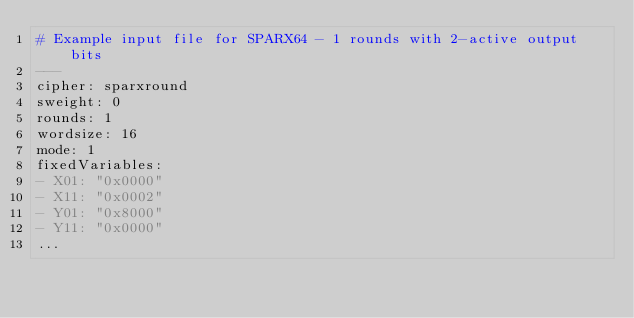<code> <loc_0><loc_0><loc_500><loc_500><_YAML_># Example input file for SPARX64 - 1 rounds with 2-active output bits
---
cipher: sparxround
sweight: 0
rounds: 1
wordsize: 16
mode: 1
fixedVariables:
- X01: "0x0000"
- X11: "0x0002"
- Y01: "0x8000"
- Y11: "0x0000"
...

</code> 